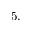<formula> <loc_0><loc_0><loc_500><loc_500>5 .</formula> 